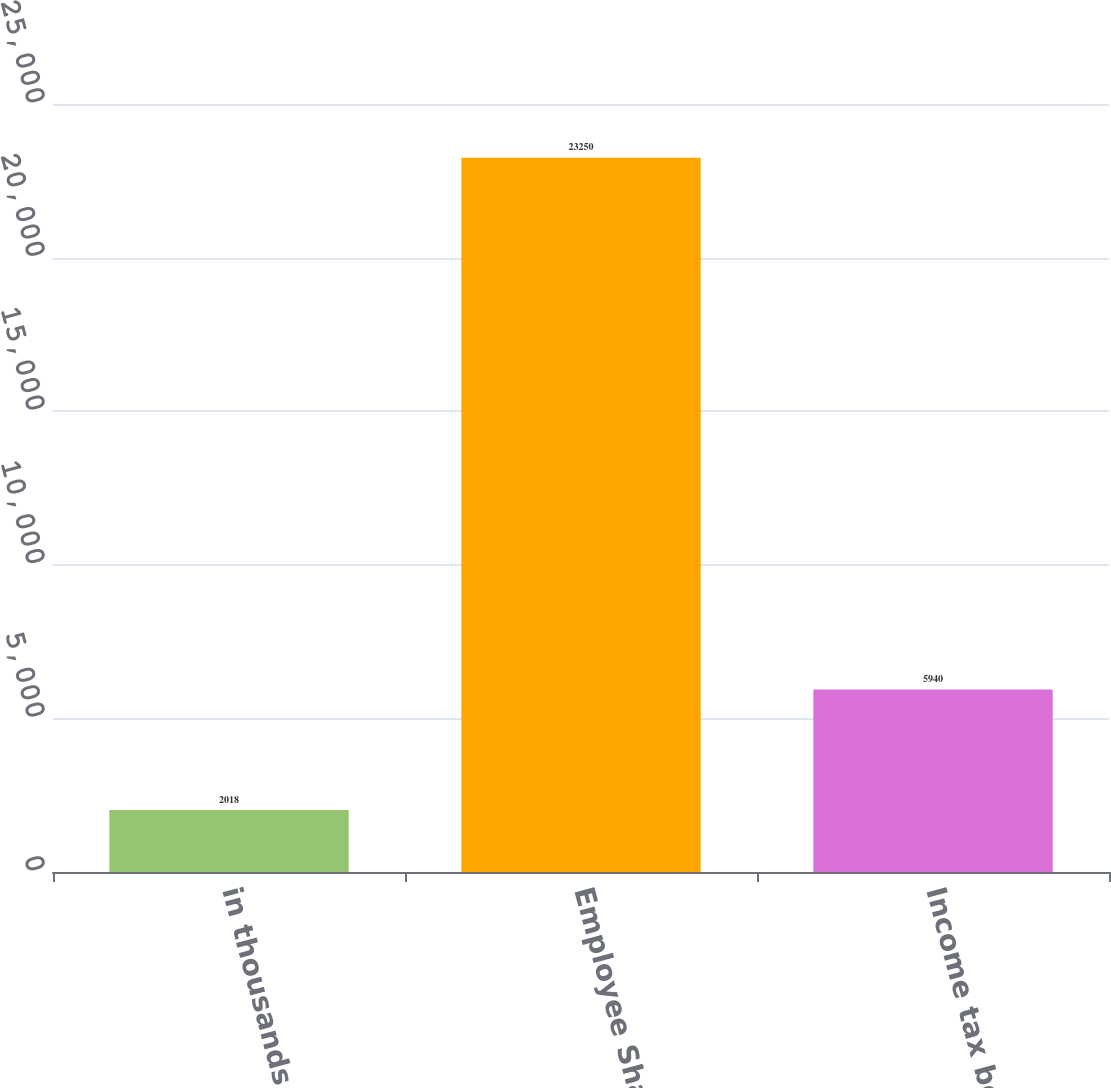Convert chart. <chart><loc_0><loc_0><loc_500><loc_500><bar_chart><fcel>in thousands<fcel>Employee Share-based<fcel>Income tax benefits<nl><fcel>2018<fcel>23250<fcel>5940<nl></chart> 